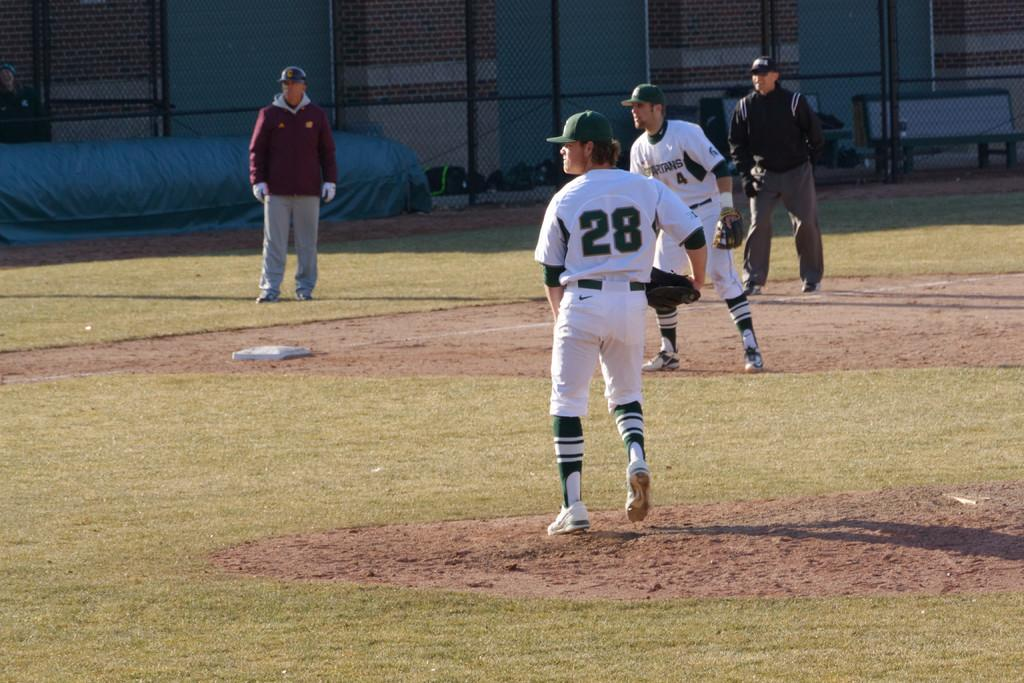<image>
Render a clear and concise summary of the photo. four men stand in a baseball field one of them has 28 on his shirt 